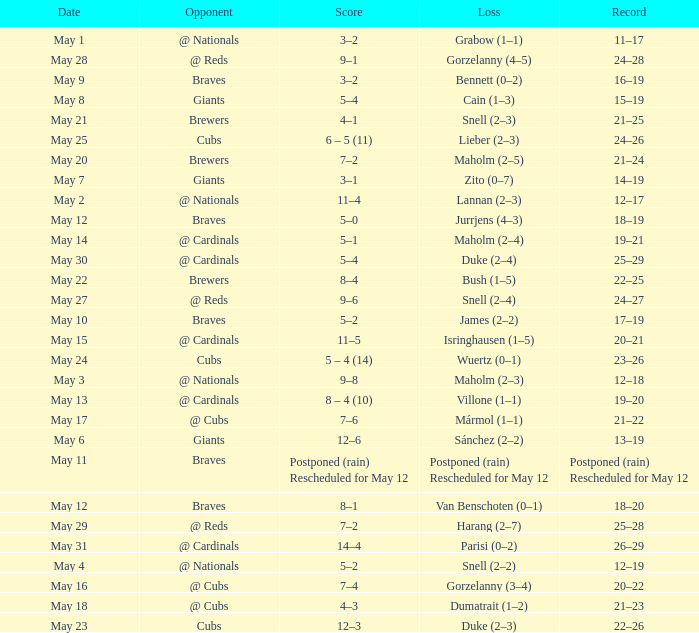Who was the opponent at the game with a score of 7–6? @ Cubs. 